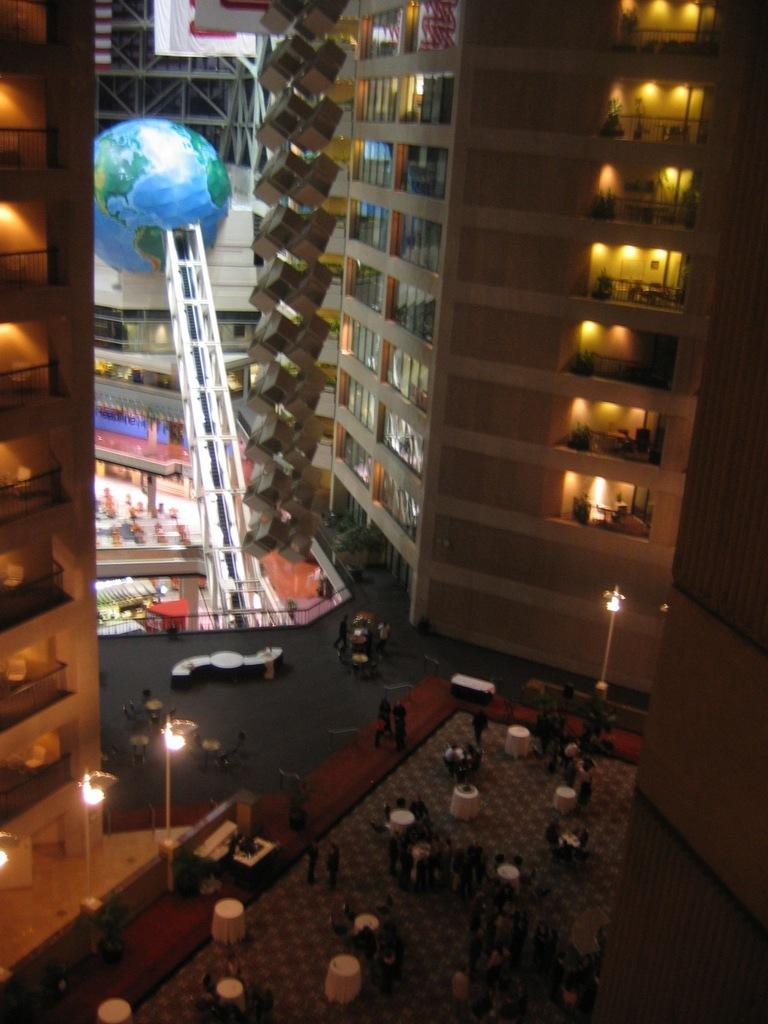What type of structures are visible in the image? There are buildings in the image. What else can be seen in the middle of the image? There are people standing in the middle of the image. Are there any objects that might be used for eating or gathering around? Yes, there are tables in the image. What type of patch can be seen on the people's clothing in the image? There is no patch visible on the people's clothing in the image. What direction is the current flowing in the image? There is no reference to a current or water in the image, so it cannot be determined. 